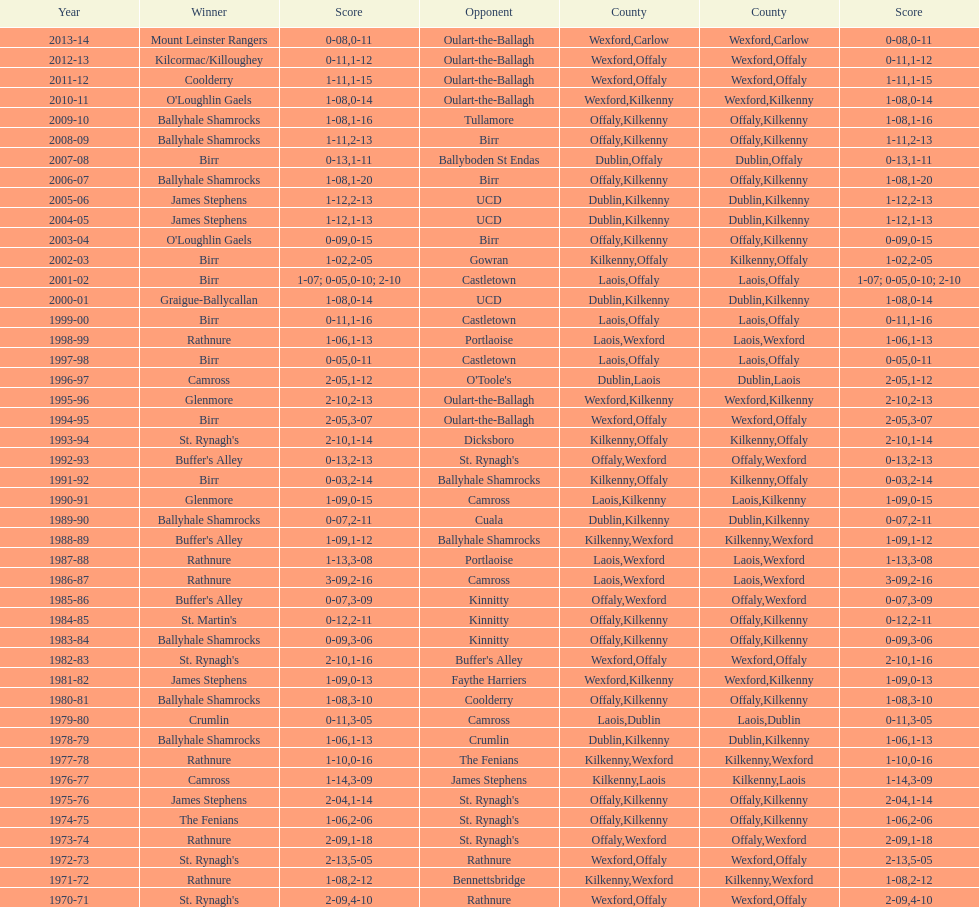Which country had the most wins? Kilkenny. 